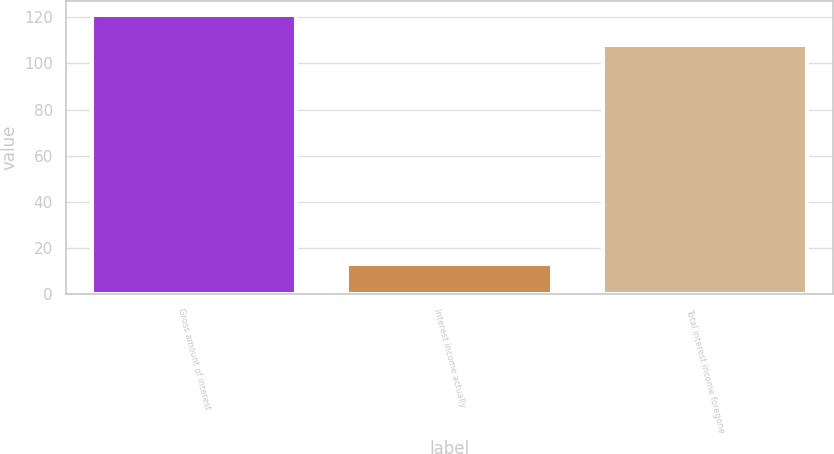<chart> <loc_0><loc_0><loc_500><loc_500><bar_chart><fcel>Gross amount of interest<fcel>Interest income actually<fcel>Total interest income foregone<nl><fcel>121<fcel>13<fcel>108<nl></chart> 